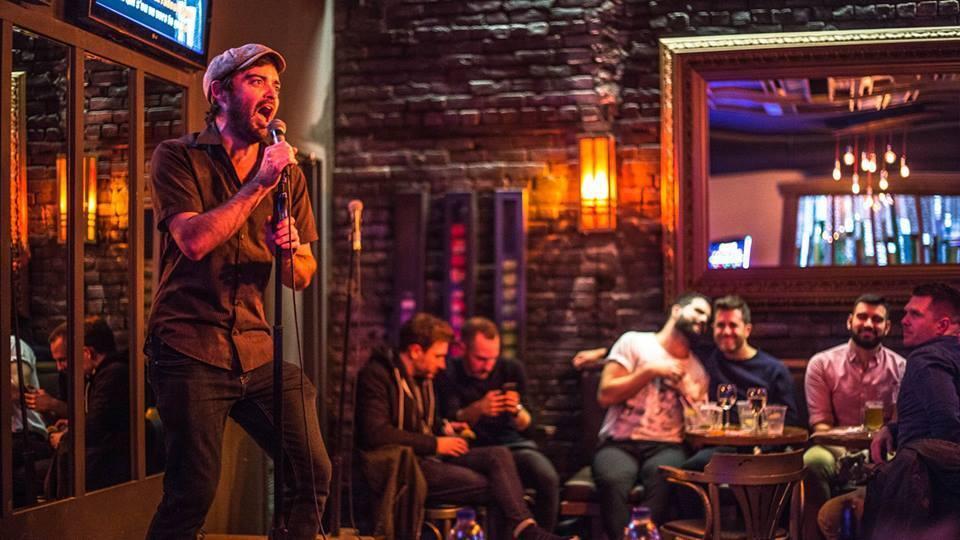What does the body language and interaction of the group of four men tell us about their relationship or the context of their conversation? The body language and interaction among the group of four men at the table suggest a sense of camaraderie and enjoyment. The close physical proximity, with one man's arm around another, and another's hand on his heart, typically signifies a shared joke or a moment of amusement among friends. Their relaxed postures and the presence of drinks on the table imply a social gathering where they are comfortable and engaged with each other. The blurred motion of their hands and facial expressions suggests laughter or animated conversation. All these cues point to a friendly and intimate dynamic, likely indicative of a group of friends enjoying a night out together. 